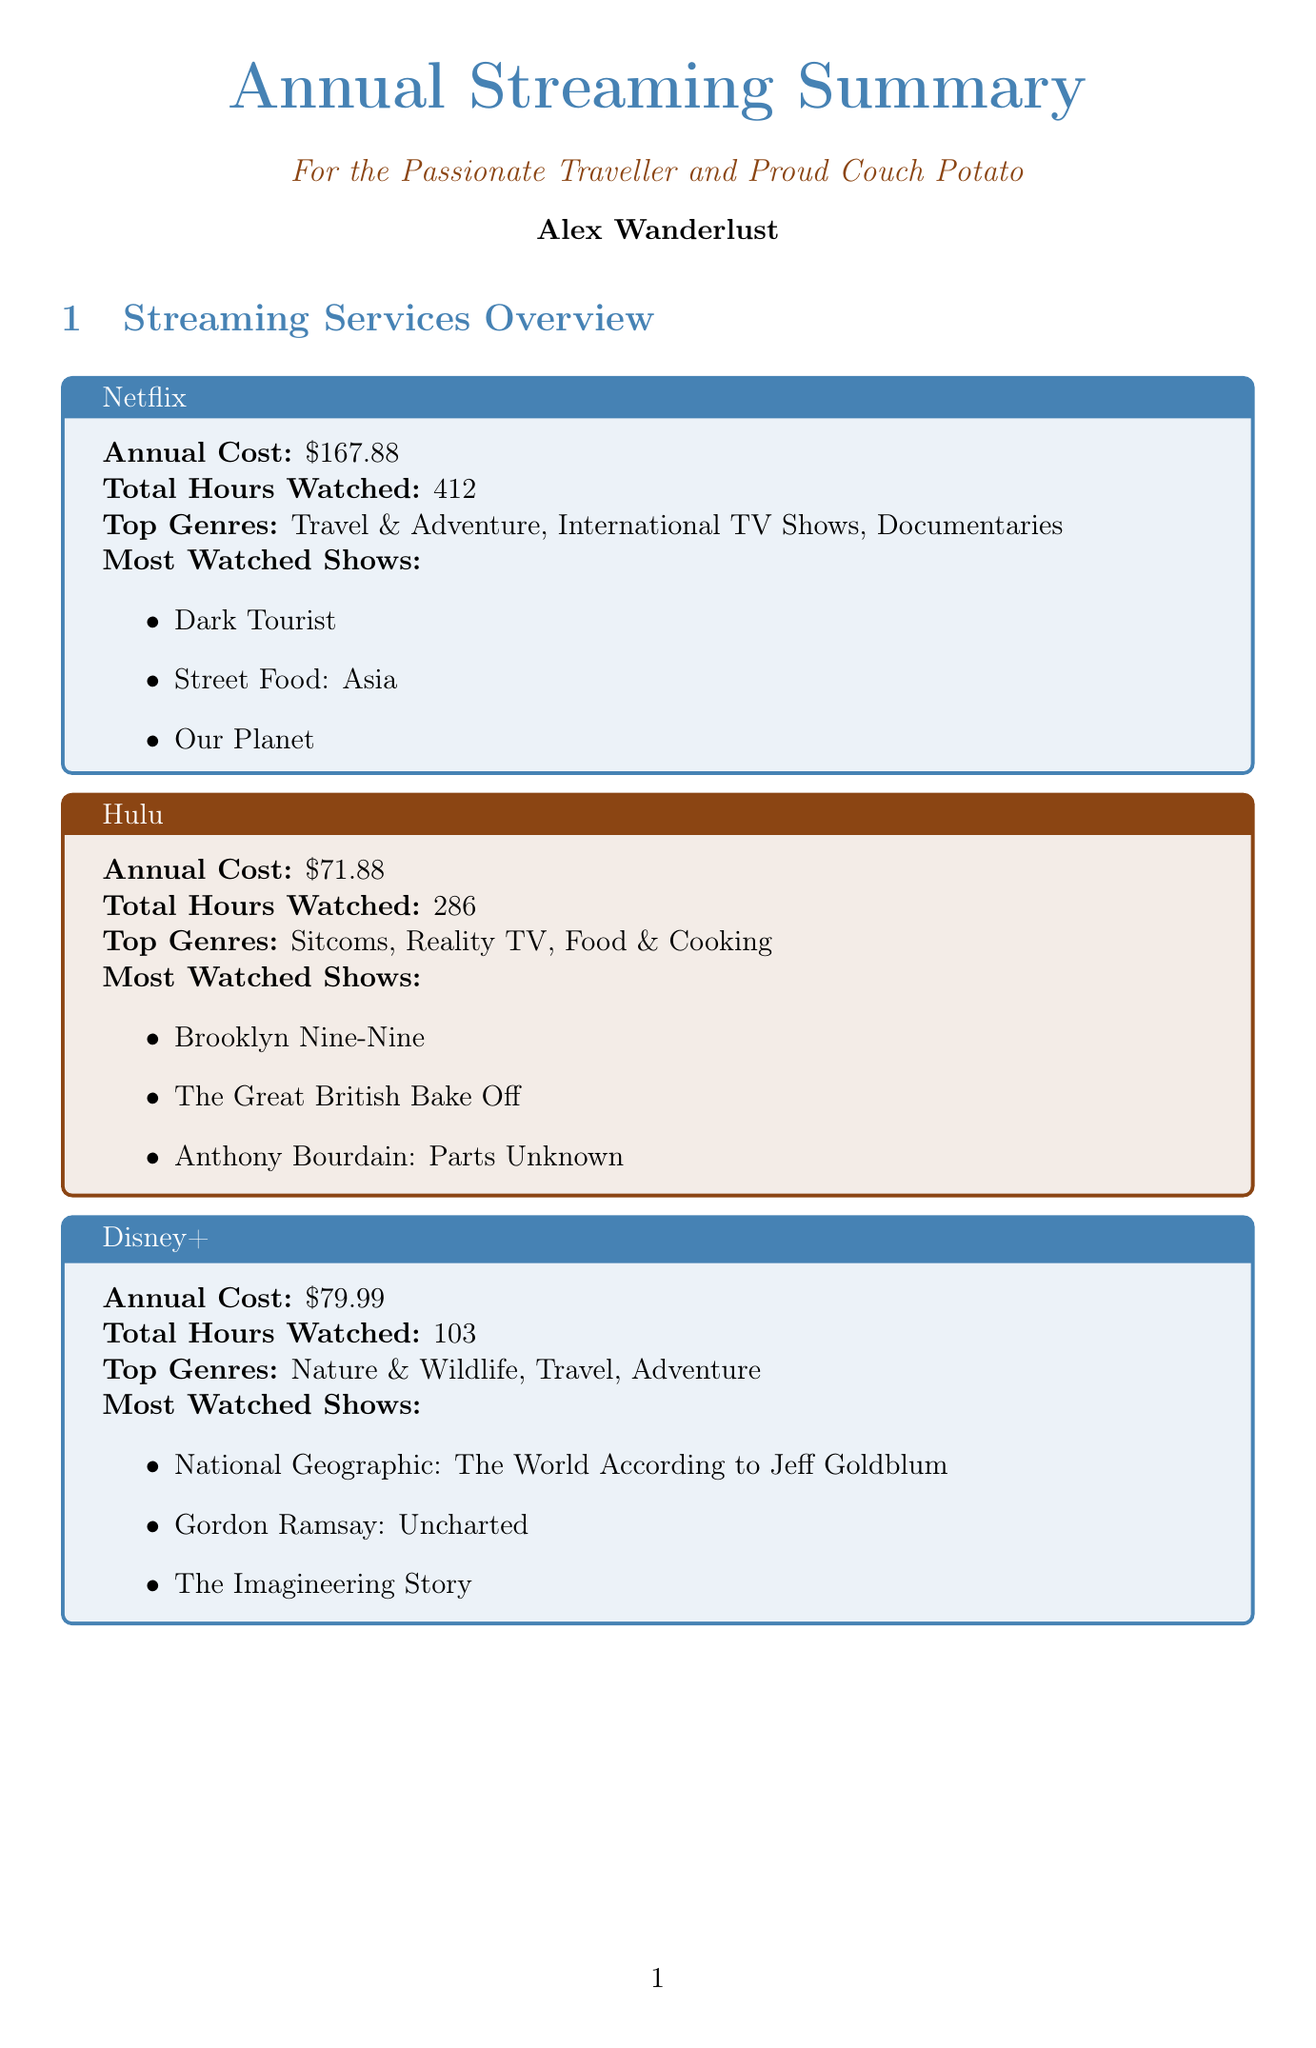What is the total annual spent on streaming services? The total annual spent is listed in the annual summary section as the sum of all costs of the individual streaming services, which amounts to $319.75.
Answer: $319.75 How many total hours were watched across all services? The total hours watched is specified in the annual summary section, which sums the hours across all streaming services to equal 801.
Answer: 801 What is the most watched show on Netflix? The document lists the most watched shows under each streaming service, and for Netflix, it is "Dark Tourist".
Answer: Dark Tourist Which month had the least active viewing? The least active month is mentioned in the annual summary section and is specified as April.
Answer: April What genre is the recommendation "The Lazy Gourmet"? The content recommendations section specifies the genre of "The Lazy Gourmet" as Cooking.
Answer: Cooking How much would one save with the suggested plan? The potential savings section states the annual savings with the suggested Netflix Standard with ads plan as $40.92.
Answer: $40.92 Which day is favored for binge-watching? The usage insights mention that Saturday is the favorite day for binge-watching.
Answer: Saturday What percentage of content watched is related to travel or food? The usage insights indicate that 73% of content watched was related to travel or food.
Answer: 73% What type of shows does Alex prefer? The user profile section outlines Alex's primary interests, specifically naming travel shows, documentaries, sitcoms, and food & cooking.
Answer: Travel shows, Documentaries, Sitcoms, Food & Cooking 